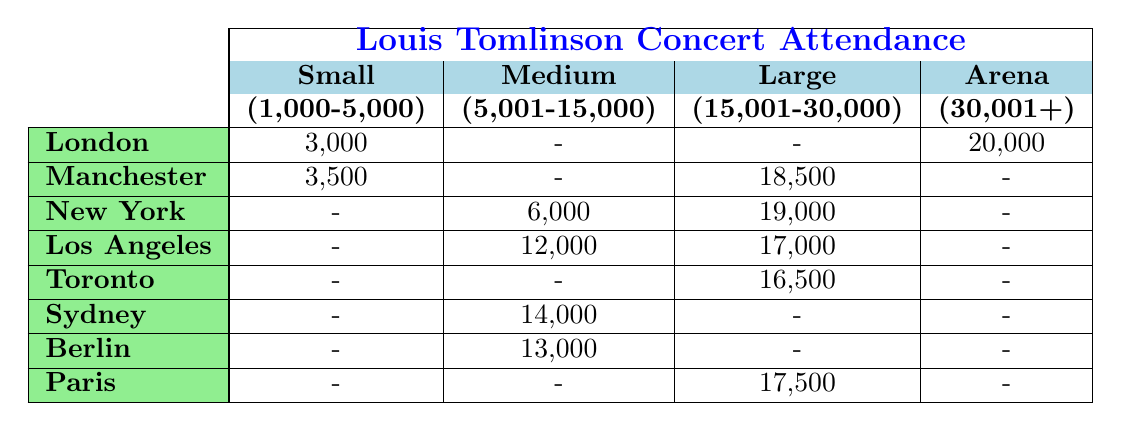What is the highest concert attendance recorded in London? In the table, under London, the highest concert attendance listed is at the O2 Arena with 20,000 attendees.
Answer: 20,000 How many concerts did Louis Tomlinson hold in small venues? The table lists two concerts in small venues: one in London with 3,000 attendees and one in Manchester with 3,500 attendees.
Answer: 2 Which city had a concert in an arena venue? The O2 Arena in London is classified as an arena venue in the table, indicating that a concert was held there.
Answer: London What was the average attendance for all concerts in medium-sized venues? The medium-sized venues listed are in Los Angeles (12,000), New York (6,000), and Sydney (14,000). Summing these values gives 32,000, and dividing by 3 results in an average of 10,667.
Answer: 10,667 Which city had the lowest concert attendance, and what was the figure? From the table, the Roundhouse in London had the lowest attendance recorded at 3,000.
Answer: 3,000 Is there a concert listed in Berlin? If so, what was the attendance? Yes, the table shows that there was a concert in Berlin at the Mercedes-Benz Arena with an attendance of 13,000.
Answer: Yes, 13,000 What is the difference in attendance between the largest and smallest venues in Sydney? The Qudos Bank Arena in Sydney had an attendance of 14,000, while there are no small venue concerts mentioned for Sydney. Thus the difference cannot be calculated.
Answer: Not applicable Which city had the highest attendance at a medium-sized venue? The medium-sized venue with the highest attendance is the concert in Sydney with 14,000 attendees.
Answer: Sydney What is the total concert attendance for all situations in Los Angeles? In Los Angeles, two concerts are listed: The Forum (12,000) and Hollywood Bowl (17,000). Adding these gives a total of 29,000.
Answer: 29,000 Is there more attendance in large venues or small venues overall? In large venues, the total is 18,500 + 19,000 + 16,500 + 17,500 = 71,500, and in small venues, the total is 3,000 + 3,500 = 6,500. Since 71,500 > 6,500, large venues have more attendance.
Answer: Large venues 